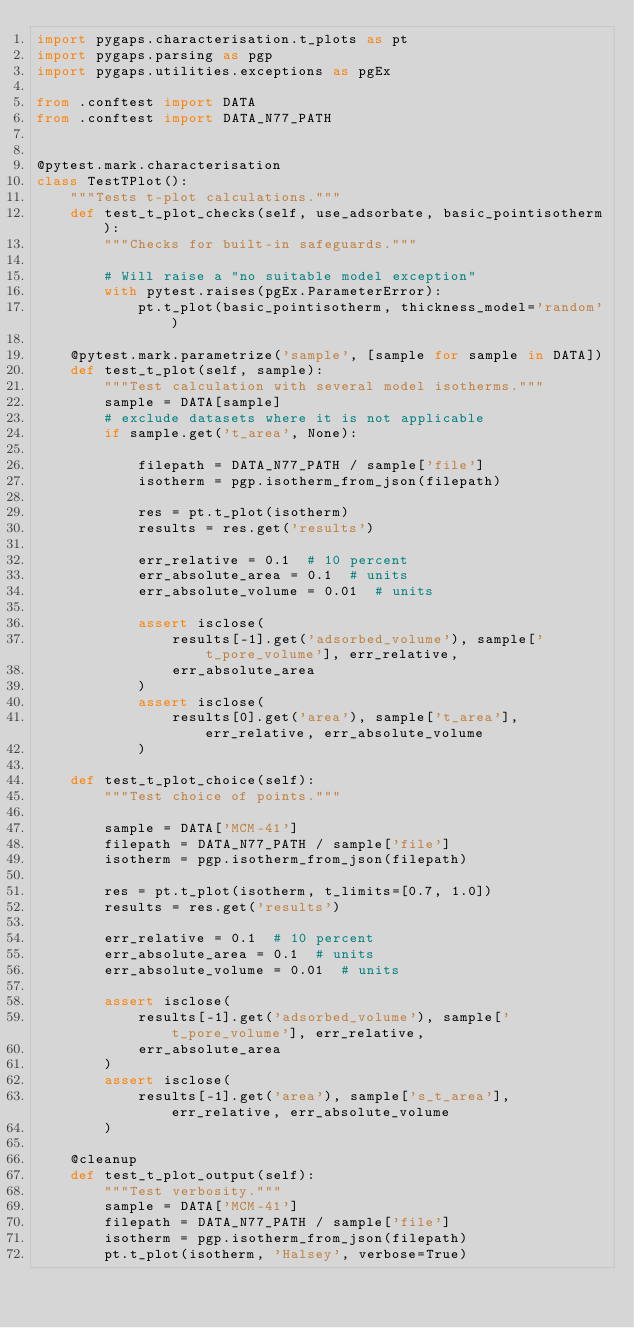<code> <loc_0><loc_0><loc_500><loc_500><_Python_>import pygaps.characterisation.t_plots as pt
import pygaps.parsing as pgp
import pygaps.utilities.exceptions as pgEx

from .conftest import DATA
from .conftest import DATA_N77_PATH


@pytest.mark.characterisation
class TestTPlot():
    """Tests t-plot calculations."""
    def test_t_plot_checks(self, use_adsorbate, basic_pointisotherm):
        """Checks for built-in safeguards."""

        # Will raise a "no suitable model exception"
        with pytest.raises(pgEx.ParameterError):
            pt.t_plot(basic_pointisotherm, thickness_model='random')

    @pytest.mark.parametrize('sample', [sample for sample in DATA])
    def test_t_plot(self, sample):
        """Test calculation with several model isotherms."""
        sample = DATA[sample]
        # exclude datasets where it is not applicable
        if sample.get('t_area', None):

            filepath = DATA_N77_PATH / sample['file']
            isotherm = pgp.isotherm_from_json(filepath)

            res = pt.t_plot(isotherm)
            results = res.get('results')

            err_relative = 0.1  # 10 percent
            err_absolute_area = 0.1  # units
            err_absolute_volume = 0.01  # units

            assert isclose(
                results[-1].get('adsorbed_volume'), sample['t_pore_volume'], err_relative,
                err_absolute_area
            )
            assert isclose(
                results[0].get('area'), sample['t_area'], err_relative, err_absolute_volume
            )

    def test_t_plot_choice(self):
        """Test choice of points."""

        sample = DATA['MCM-41']
        filepath = DATA_N77_PATH / sample['file']
        isotherm = pgp.isotherm_from_json(filepath)

        res = pt.t_plot(isotherm, t_limits=[0.7, 1.0])
        results = res.get('results')

        err_relative = 0.1  # 10 percent
        err_absolute_area = 0.1  # units
        err_absolute_volume = 0.01  # units

        assert isclose(
            results[-1].get('adsorbed_volume'), sample['t_pore_volume'], err_relative,
            err_absolute_area
        )
        assert isclose(
            results[-1].get('area'), sample['s_t_area'], err_relative, err_absolute_volume
        )

    @cleanup
    def test_t_plot_output(self):
        """Test verbosity."""
        sample = DATA['MCM-41']
        filepath = DATA_N77_PATH / sample['file']
        isotherm = pgp.isotherm_from_json(filepath)
        pt.t_plot(isotherm, 'Halsey', verbose=True)
</code> 